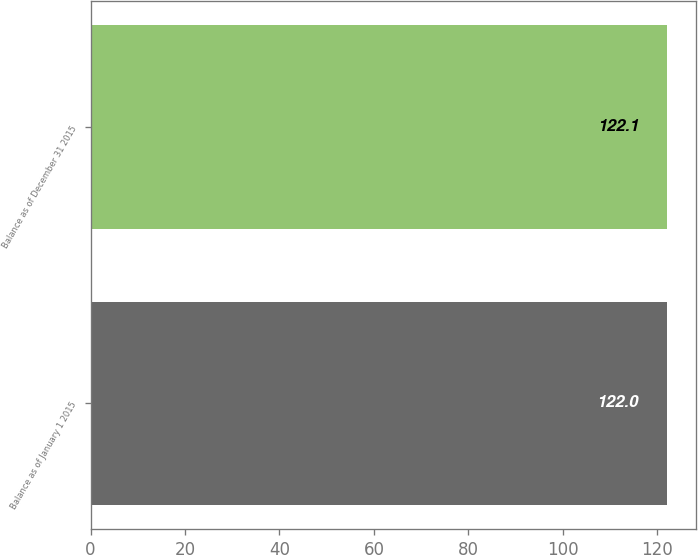Convert chart. <chart><loc_0><loc_0><loc_500><loc_500><bar_chart><fcel>Balance as of January 1 2015<fcel>Balance as of December 31 2015<nl><fcel>122<fcel>122.1<nl></chart> 